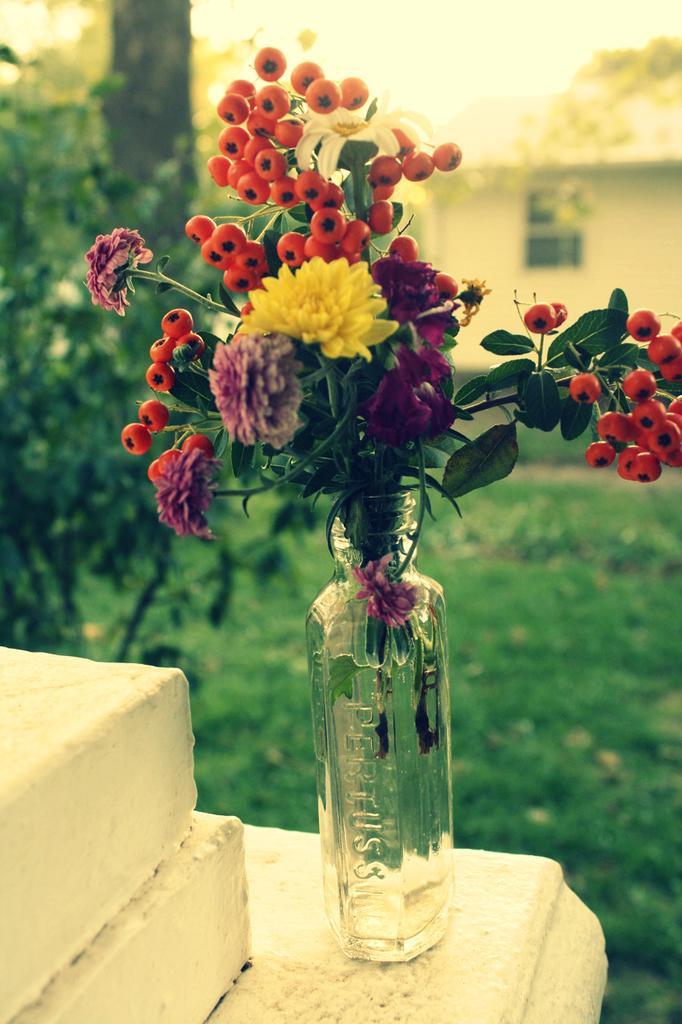Please provide a concise description of this image. In the image there is flower in bottle and in front there is garden and at the background there is a home. 